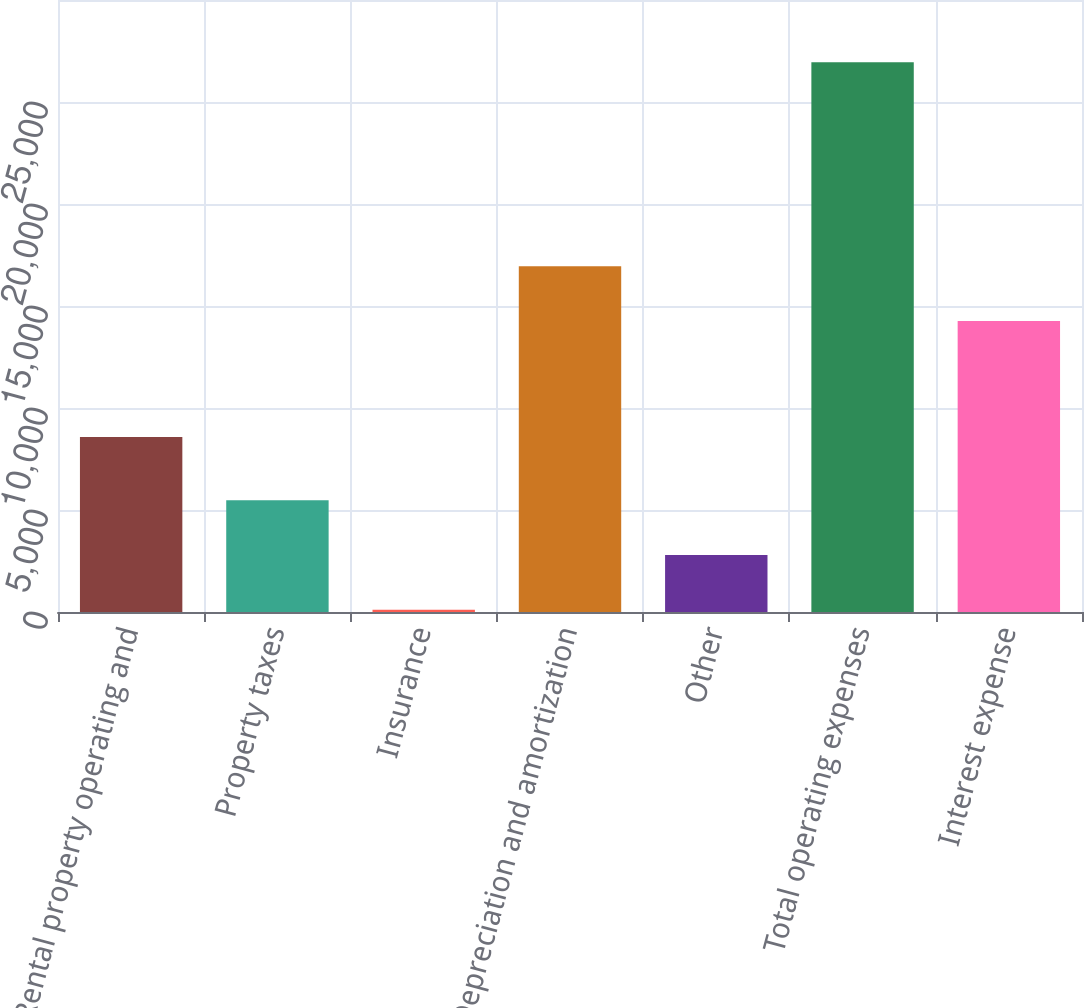<chart> <loc_0><loc_0><loc_500><loc_500><bar_chart><fcel>Rental property operating and<fcel>Property taxes<fcel>Insurance<fcel>Depreciation and amortization<fcel>Other<fcel>Total operating expenses<fcel>Interest expense<nl><fcel>8577<fcel>5478.8<fcel>112<fcel>16951.4<fcel>2795.4<fcel>26946<fcel>14268<nl></chart> 